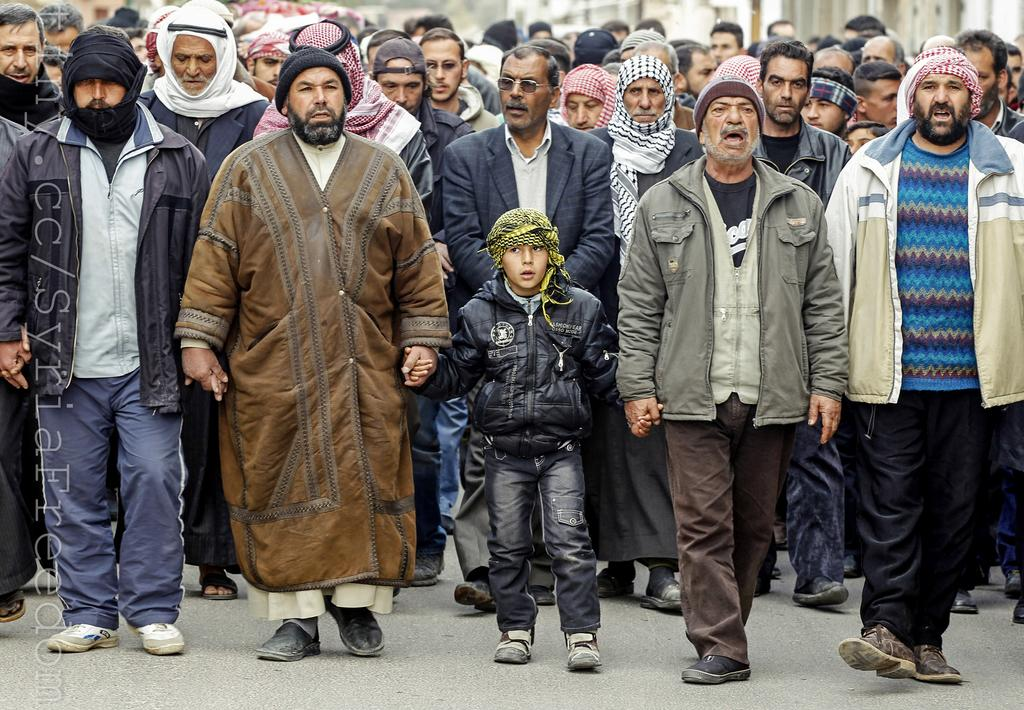What can be seen in the foreground of the image? There is a group of standing people in the front of the image. What is visible in the background of the image? There are buildings in the background of the image. What type of trousers is the rat wearing in the image? There is no rat present in the image, and therefore no trousers can be observed. 